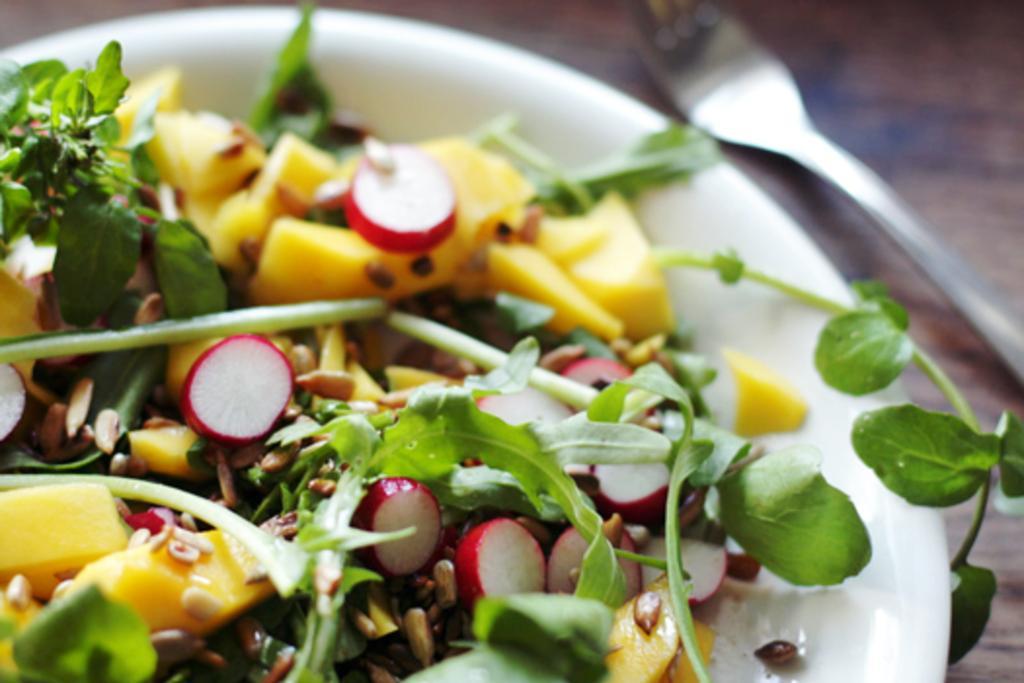Can you describe this image briefly? In this picture we can see a table. On the table we can see a plate which contains food and fork. 